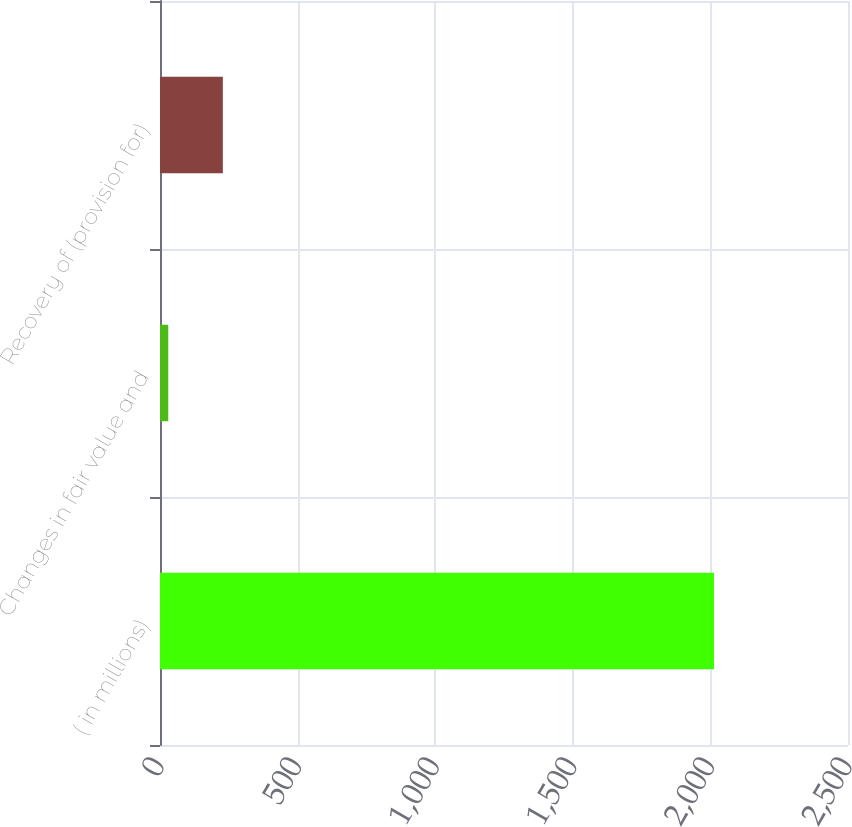Convert chart. <chart><loc_0><loc_0><loc_500><loc_500><bar_chart><fcel>( in millions)<fcel>Changes in fair value and<fcel>Recovery of (provision for)<nl><fcel>2013<fcel>30<fcel>228.3<nl></chart> 